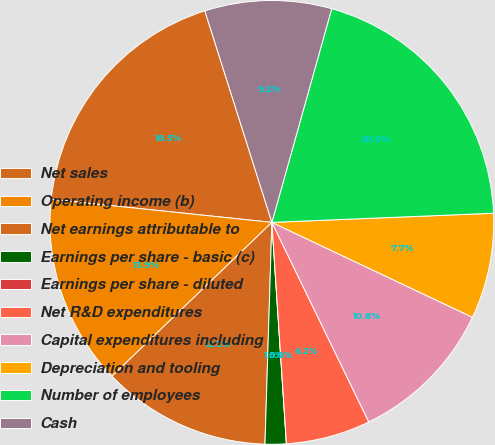Convert chart. <chart><loc_0><loc_0><loc_500><loc_500><pie_chart><fcel>Net sales<fcel>Operating income (b)<fcel>Net earnings attributable to<fcel>Earnings per share - basic (c)<fcel>Earnings per share - diluted<fcel>Net R&D expenditures<fcel>Capital expenditures including<fcel>Depreciation and tooling<fcel>Number of employees<fcel>Cash<nl><fcel>18.46%<fcel>13.85%<fcel>12.31%<fcel>1.54%<fcel>0.0%<fcel>6.15%<fcel>10.77%<fcel>7.69%<fcel>20.0%<fcel>9.23%<nl></chart> 